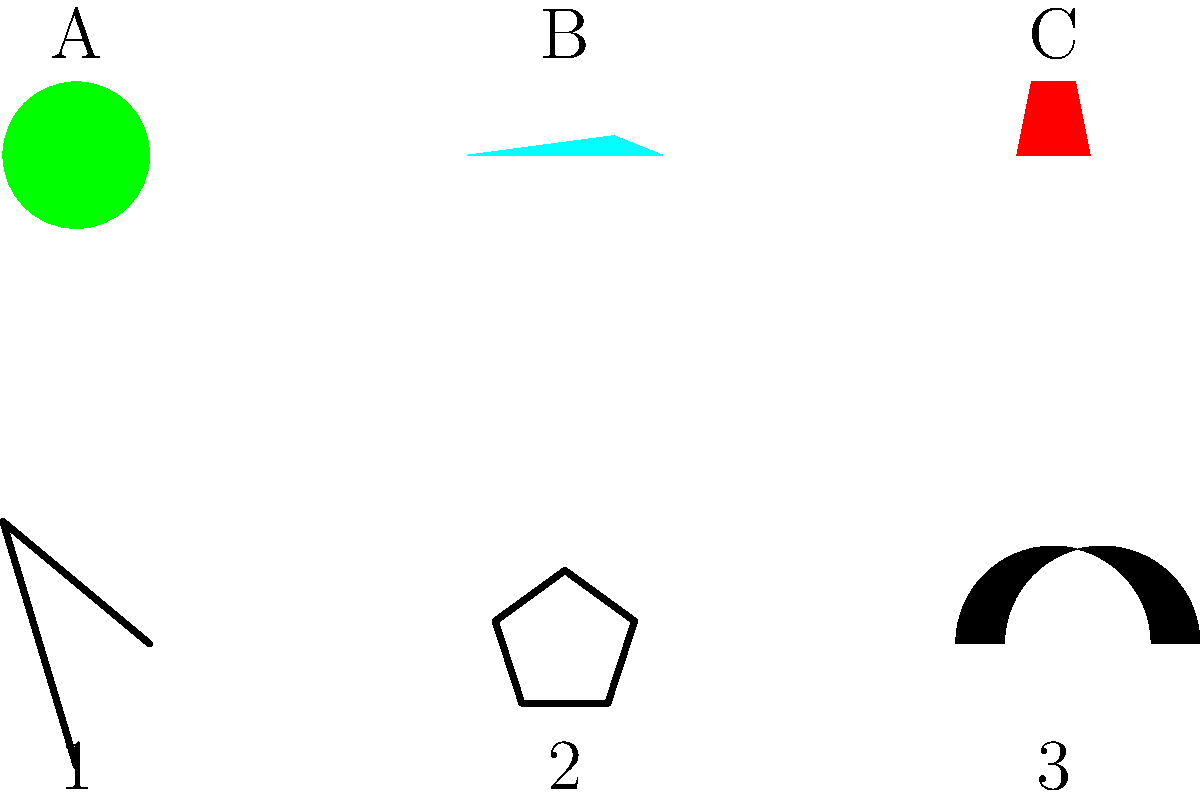Match the food items (A, B, C) with the religious symbols (1, 2, 3) based on dietary practices. Which combination correctly represents the relationship between the food and the religion it is most associated with? To answer this question, we need to analyze the dietary practices of different religions:

1. The cross (1) represents Christianity. While Christianity doesn't have strict dietary laws, wine (C) is significant in Christian rituals, particularly in the Eucharist or Communion.

2. The Star of David (2) represents Judaism. Jewish dietary laws (kashrut) prohibit the consumption of certain foods, including pork. However, apples (A) are kosher and often used in Jewish traditions, such as dipping apples in honey on Rosh Hashanah.

3. The crescent moon (3) represents Islam. Islamic dietary laws (halal) prohibit the consumption of pork and alcohol. Fish (B) is generally considered halal and is permissible for Muslims to eat.

Therefore, the correct matching is:
A (Apple) - 2 (Star of David/Judaism)
B (Fish) - 3 (Crescent/Islam)
C (Wine) - 1 (Cross/Christianity)
Answer: A2, B3, C1 